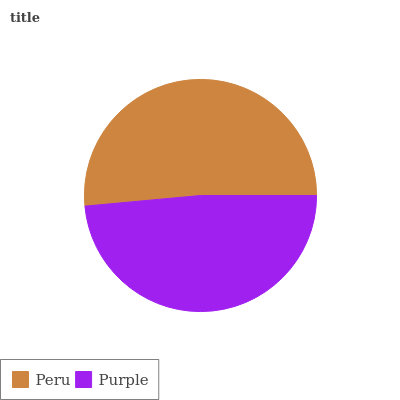Is Purple the minimum?
Answer yes or no. Yes. Is Peru the maximum?
Answer yes or no. Yes. Is Purple the maximum?
Answer yes or no. No. Is Peru greater than Purple?
Answer yes or no. Yes. Is Purple less than Peru?
Answer yes or no. Yes. Is Purple greater than Peru?
Answer yes or no. No. Is Peru less than Purple?
Answer yes or no. No. Is Peru the high median?
Answer yes or no. Yes. Is Purple the low median?
Answer yes or no. Yes. Is Purple the high median?
Answer yes or no. No. Is Peru the low median?
Answer yes or no. No. 